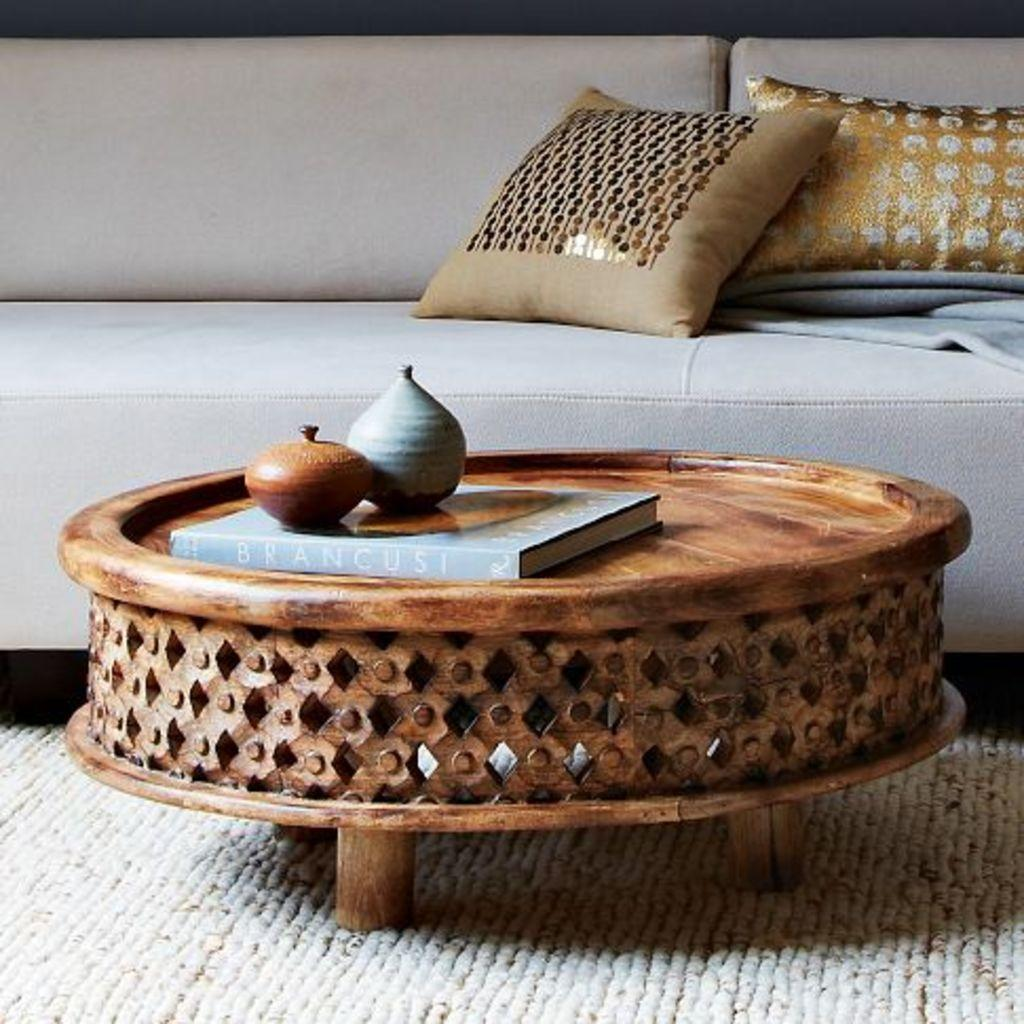What type of furniture is present in the image? There is a couch in the image. What is placed on the couch? There is a pillow on the couch. What other piece of furniture is visible in the image? There is a table in the image. What object can be seen on the table? There is a book on the table. What type of floor covering is present in the image? There is a floor mat in the image. What nation is represented by the wall in the image? There is no wall present in the image, so it is not possible to determine which nation might be represented. 